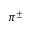<formula> <loc_0><loc_0><loc_500><loc_500>\pi ^ { \pm }</formula> 